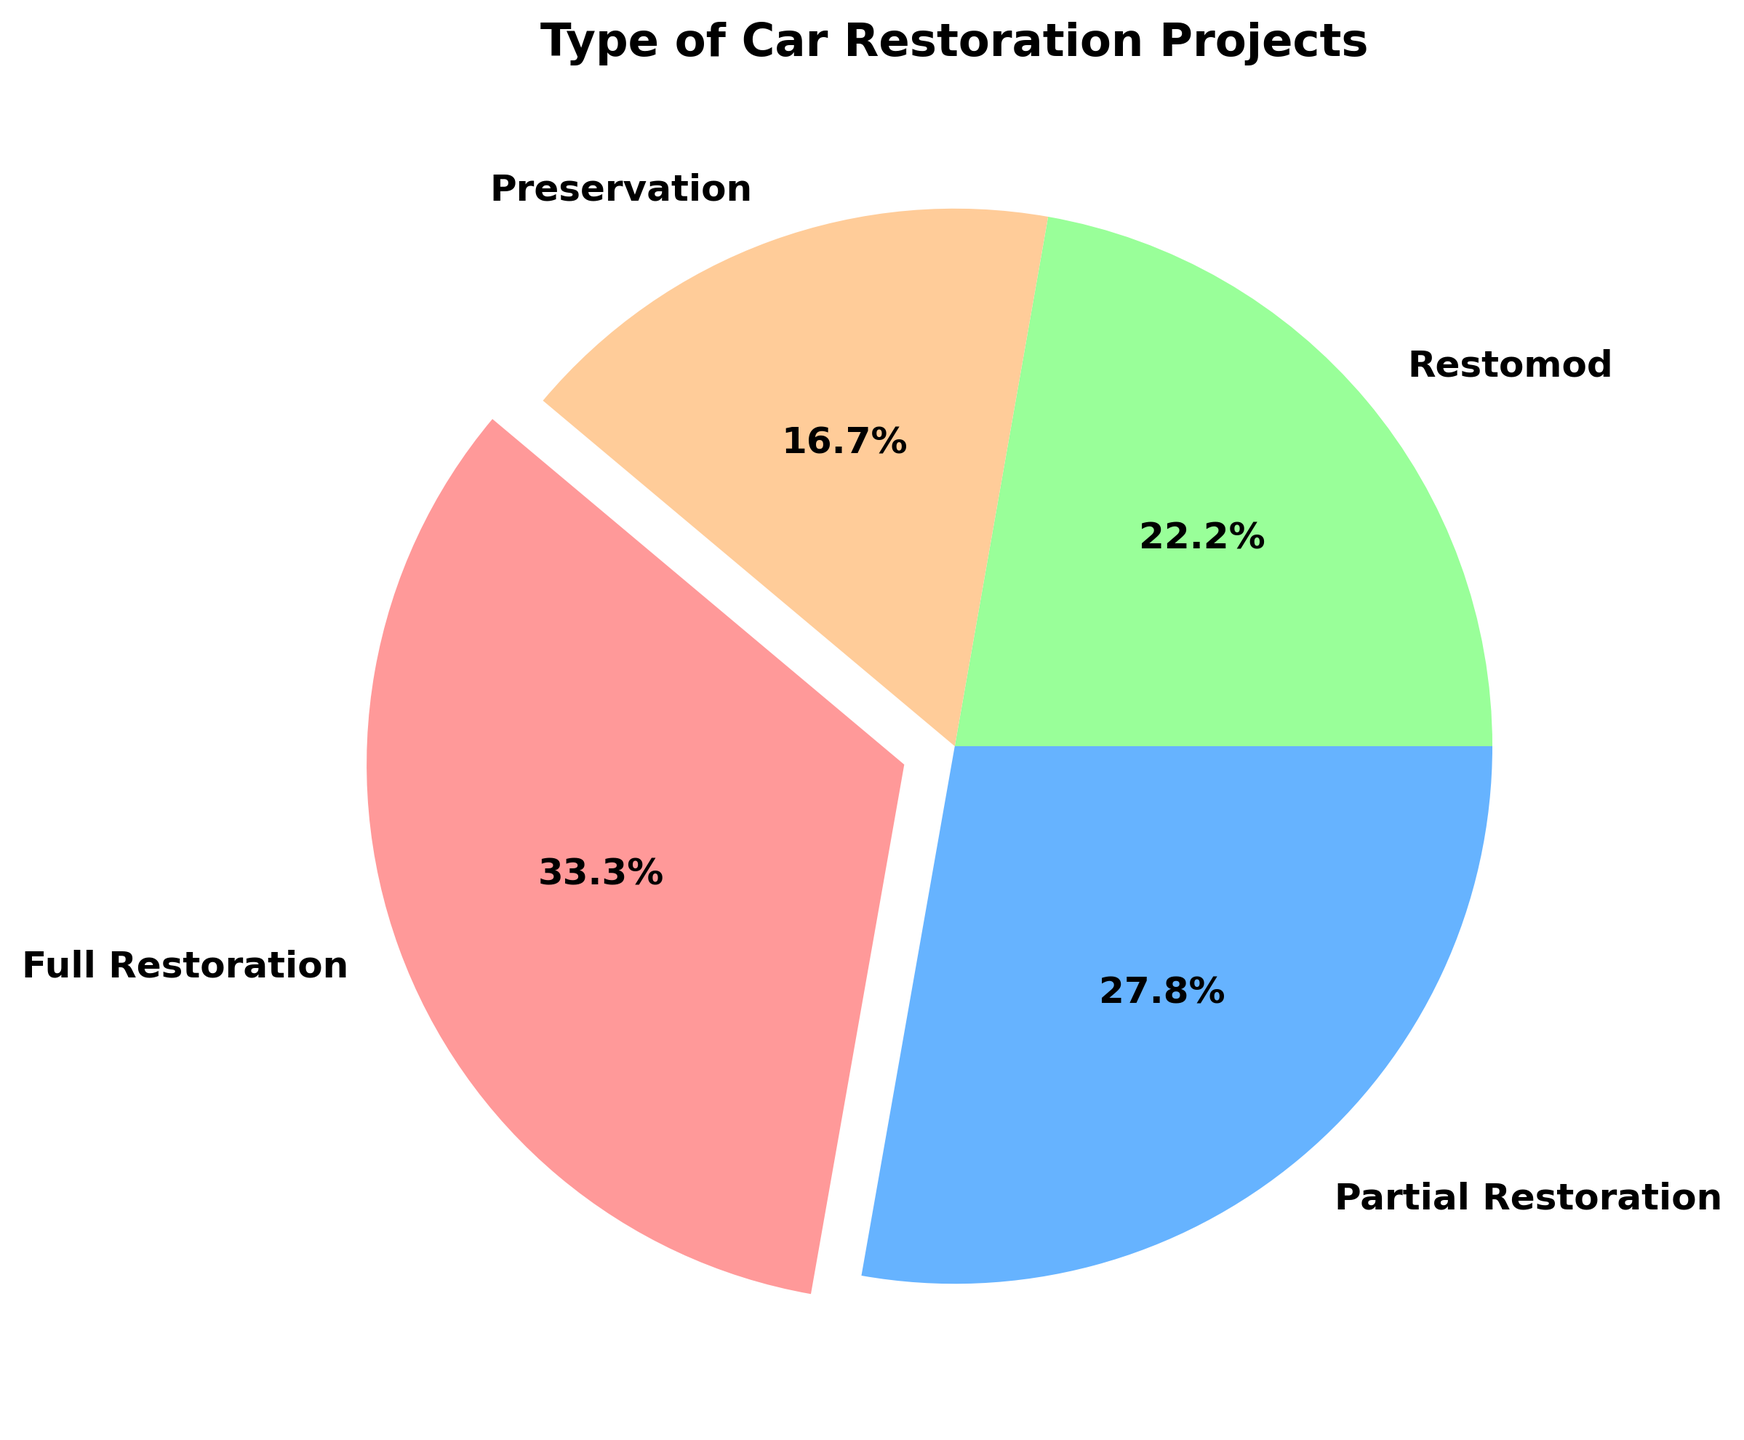What percentage of the restoration projects are Full Restoration? Look at the pie chart and locate the segment labeled "Full Restoration." The percentage will be displayed within the segment.
Answer: 30% How many more projects are classified as Full Restoration compared to Preservation? The chart shows that there are 30 Full Restoration projects and 15 Preservation projects. Subtract the number of Preservation projects from Full Restoration projects (30 - 15).
Answer: 15 Which type of restoration project is the least common? Identify the segment with the smallest percentage on the pie chart. The label within this segment will tell you the type of project.
Answer: Preservation What is the combined percentage of Partial Restoration and Restomod projects? Locate the segments labeled "Partial Restoration" and "Restomod." Sum their percentages (25% + 20%).
Answer: 45% Is the number of Restomod projects greater than that of Preservation projects? Compare the numbers for Restomod (20) and Preservation (15) projects shown in each segment.
Answer: Yes Which project type has the highest percentage in the pie chart? Identify the segment with the largest percentage. The label within this segment indicates the project type.
Answer: Full Restoration What are the colors used to represent Full Restoration and Restomod projects? Look at the colors assigned to the segments labeled "Full Restoration" and "Restomod."
Answer: Full Restoration: Red, Restomod: Green If you look at the three least common project types, what percentage do they collectively represent? Identify the three segments with the smallest percentages: Partial Restoration (25%), Restomod (20%), and Preservation (15%). Sum these percentages (25% + 20% + 15%).
Answer: 60% How much more common are Full Restoration projects compared to Restomod projects in terms of percentage? Subtract the percentage of Restomod projects (20%) from the percentage of Full Restoration projects (30%).
Answer: 10% What fraction of the total projects are either Full Restoration or Preservation? Sum the counts for Full Restoration (30) and Preservation (15): 30 + 15 = 45. The total number of projects is 90. Divide the combined count by the total (45/90) and reduce the fraction.
Answer: 1/2 